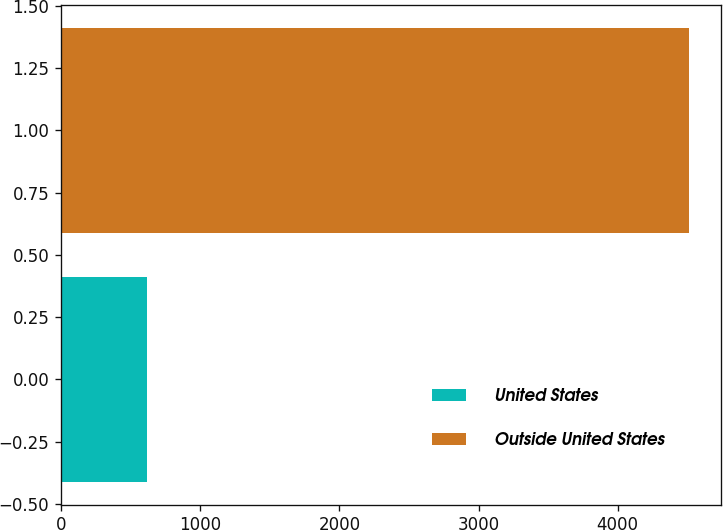Convert chart. <chart><loc_0><loc_0><loc_500><loc_500><bar_chart><fcel>United States<fcel>Outside United States<nl><fcel>617<fcel>4515<nl></chart> 